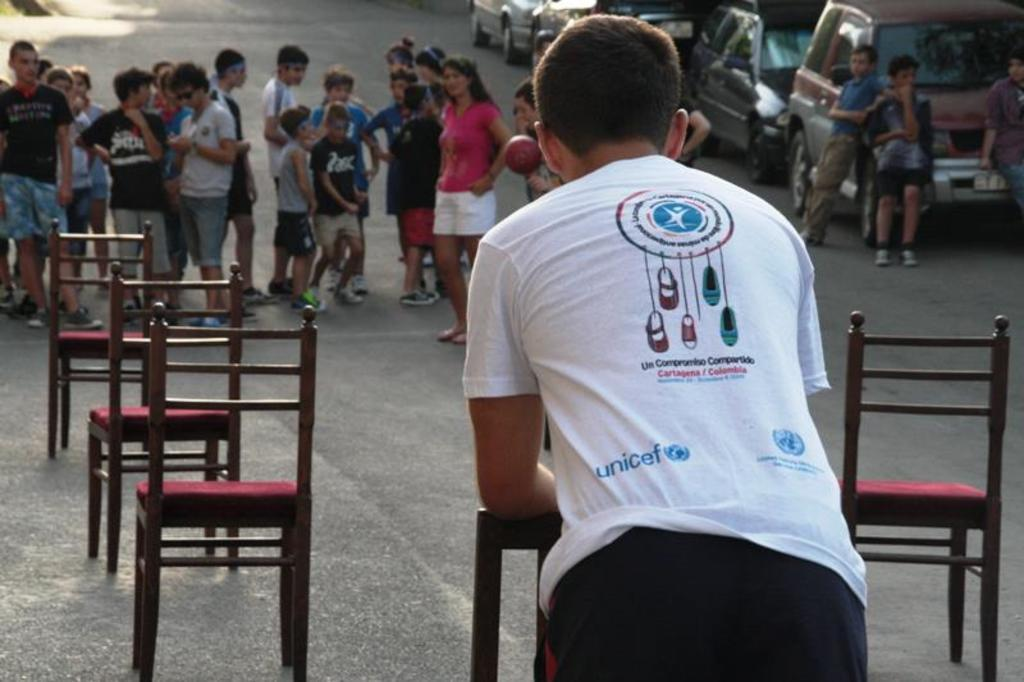What is happening on the road in the image? There are many persons standing on the road, and chairs are kept on the road. What can be seen to the right of the road? Cars are parked to the right. What is visible at the bottom of the image? There is a road visible at the bottom of the image. What type of pest can be seen crawling on the chairs in the image? There are no pests visible in the image; it only shows persons standing on the road and chairs kept on the road. How many feet are visible in the image? The number of feet visible in the image cannot be determined from the provided facts. 